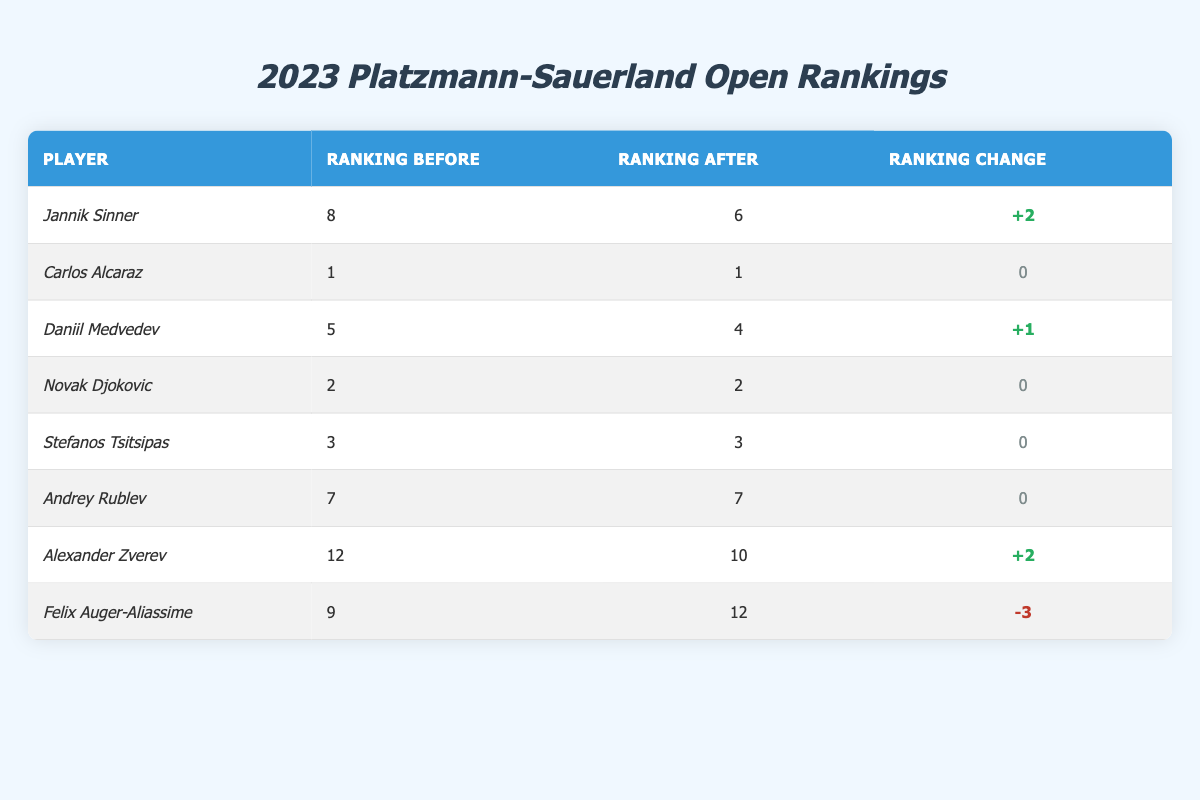What was Jannik Sinner's ranking before the tournament? The table lists Jannik Sinner's ranking, which shows his ranking before the 2023 Platzmann-Sauerland Open was 8.
Answer: 8 How many players maintained their ranking after the Platzmann-Sauerland Open? From the table, Carlos Alcaraz, Novak Djokovic, Stefanos Tsitsipas, and Andrey Rublev all have a ranking change of 0, indicating they maintained their ranking. This totals to 4 players.
Answer: 4 Which player had the largest drop in ranking after the tournament? The table shows Felix Auger-Aliassime with a ranking change of -3, which is the largest decrease among all players listed.
Answer: Felix Auger-Aliassime What is the total ranking change for players who improved their rankings? Jannik Sinner (+2) and Alexander Zverev (+2) both improved their rankings, summing their changes gives +2 +2 = +4.
Answer: +4 Is it true that only one player improved their ranking by more than 1 position? The table shows both Jannik Sinner and Alexander Zverev improved their rankings by 2 positions, indicating that more than one player improved their ranking by more than 1 position. Thus, this statement is false.
Answer: No What was the average ranking change for all players? The changes in ranking are +2, 0, +1, 0, 0, 0, +2, -3. Summing these gives +2 + 0 + 1 + 0 + 0 + 0 + 2 - 3 = 2. There are 8 players, so the average change is 2/8 = 0.25.
Answer: 0.25 How many players are ranked above Alexander Zverev after the tournament? After the tournament, Alexander Zverev is ranked 10. The players ranked above him are Carlos Alcaraz (1), Novak Djokovic (2), Stefanos Tsitsipas (3), Daniil Medvedev (4), Jannik Sinner (6), and Andrey Rublev (7) totaling to 6 players.
Answer: 6 Which player ranked 5th before the tournament? According to the table, Daniil Medvedev was ranked 5th before the tournament.
Answer: Daniil Medvedev Was there any player that decreased their ranking among the top 10 players? The table shows that Felix Auger-Aliassime, previously ranked 9, decreased to 12. He is among the top 10 and experienced a ranking decrease. Thus, the answer is yes.
Answer: Yes 